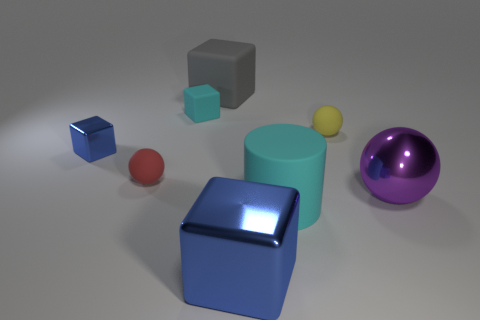Subtract all rubber spheres. How many spheres are left? 1 Subtract all gray blocks. How many blocks are left? 3 Add 1 big purple things. How many objects exist? 9 Subtract all balls. How many objects are left? 5 Subtract 2 spheres. How many spheres are left? 1 Subtract all purple balls. Subtract all cyan cylinders. How many balls are left? 2 Subtract all yellow cylinders. How many gray cubes are left? 1 Subtract all tiny blue metallic blocks. Subtract all large objects. How many objects are left? 3 Add 2 large purple things. How many large purple things are left? 3 Add 5 cylinders. How many cylinders exist? 6 